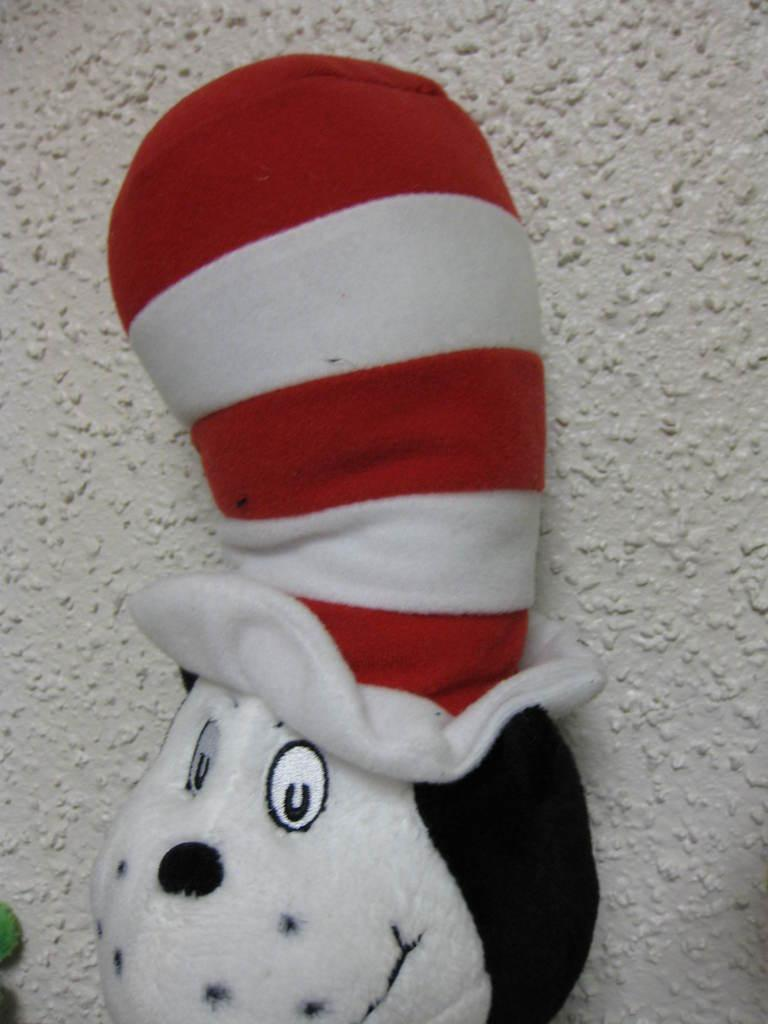What is the main object in the foreground of the image? There is a toy with a red and white hat in the foreground of the image. What can be seen in the background of the image? There is a wall in the background of the image. What title is given to the book that the toy is reading in the image? There is no book or reading activity depicted in the image, so there is no title to mention. 